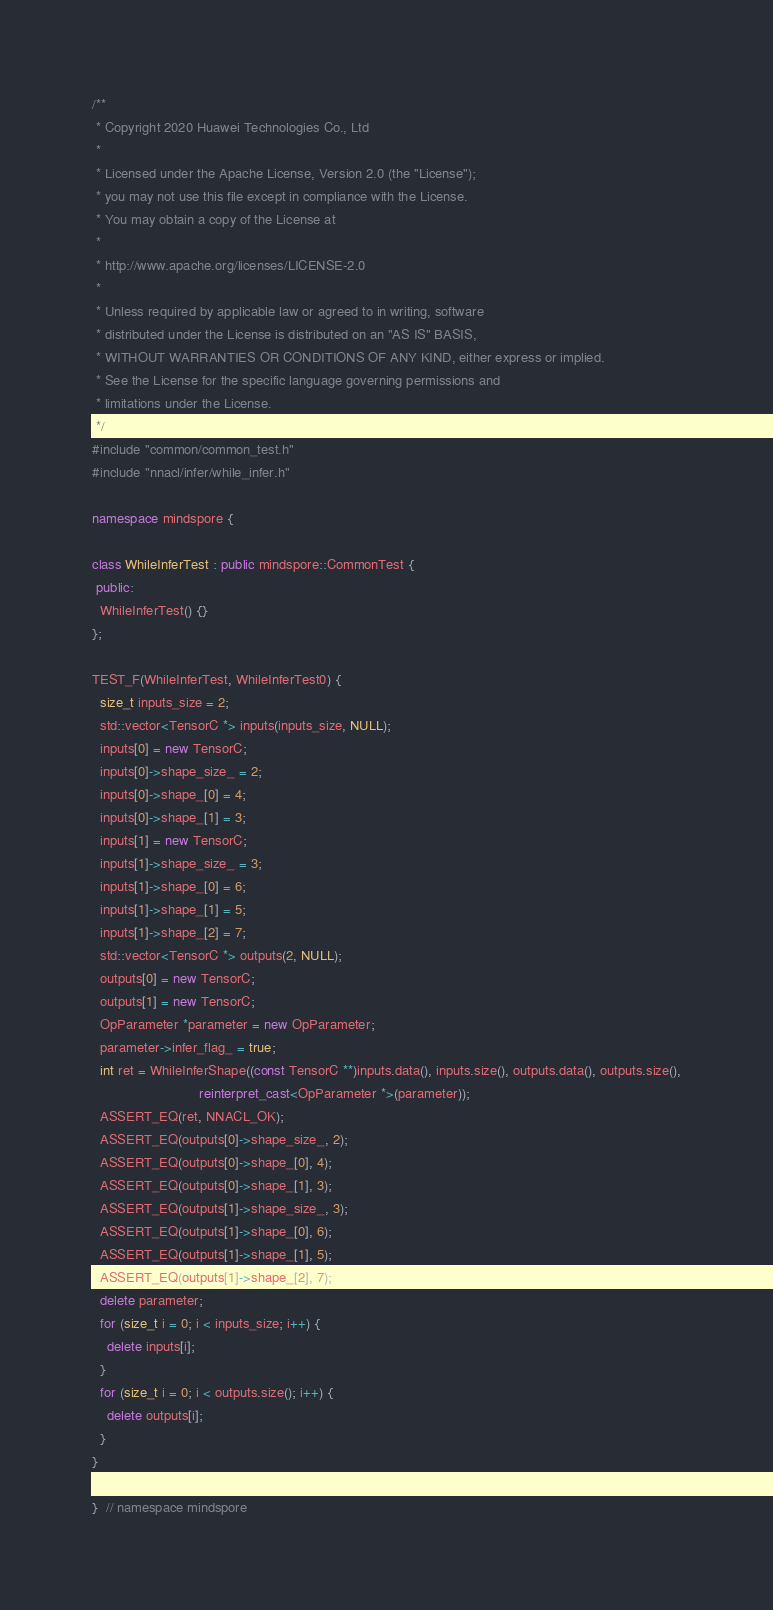Convert code to text. <code><loc_0><loc_0><loc_500><loc_500><_C++_>/**
 * Copyright 2020 Huawei Technologies Co., Ltd
 *
 * Licensed under the Apache License, Version 2.0 (the "License");
 * you may not use this file except in compliance with the License.
 * You may obtain a copy of the License at
 *
 * http://www.apache.org/licenses/LICENSE-2.0
 *
 * Unless required by applicable law or agreed to in writing, software
 * distributed under the License is distributed on an "AS IS" BASIS,
 * WITHOUT WARRANTIES OR CONDITIONS OF ANY KIND, either express or implied.
 * See the License for the specific language governing permissions and
 * limitations under the License.
 */
#include "common/common_test.h"
#include "nnacl/infer/while_infer.h"

namespace mindspore {

class WhileInferTest : public mindspore::CommonTest {
 public:
  WhileInferTest() {}
};

TEST_F(WhileInferTest, WhileInferTest0) {
  size_t inputs_size = 2;
  std::vector<TensorC *> inputs(inputs_size, NULL);
  inputs[0] = new TensorC;
  inputs[0]->shape_size_ = 2;
  inputs[0]->shape_[0] = 4;
  inputs[0]->shape_[1] = 3;
  inputs[1] = new TensorC;
  inputs[1]->shape_size_ = 3;
  inputs[1]->shape_[0] = 6;
  inputs[1]->shape_[1] = 5;
  inputs[1]->shape_[2] = 7;
  std::vector<TensorC *> outputs(2, NULL);
  outputs[0] = new TensorC;
  outputs[1] = new TensorC;
  OpParameter *parameter = new OpParameter;
  parameter->infer_flag_ = true;
  int ret = WhileInferShape((const TensorC **)inputs.data(), inputs.size(), outputs.data(), outputs.size(),
                            reinterpret_cast<OpParameter *>(parameter));
  ASSERT_EQ(ret, NNACL_OK);
  ASSERT_EQ(outputs[0]->shape_size_, 2);
  ASSERT_EQ(outputs[0]->shape_[0], 4);
  ASSERT_EQ(outputs[0]->shape_[1], 3);
  ASSERT_EQ(outputs[1]->shape_size_, 3);
  ASSERT_EQ(outputs[1]->shape_[0], 6);
  ASSERT_EQ(outputs[1]->shape_[1], 5);
  ASSERT_EQ(outputs[1]->shape_[2], 7);
  delete parameter;
  for (size_t i = 0; i < inputs_size; i++) {
    delete inputs[i];
  }
  for (size_t i = 0; i < outputs.size(); i++) {
    delete outputs[i];
  }
}

}  // namespace mindspore
</code> 